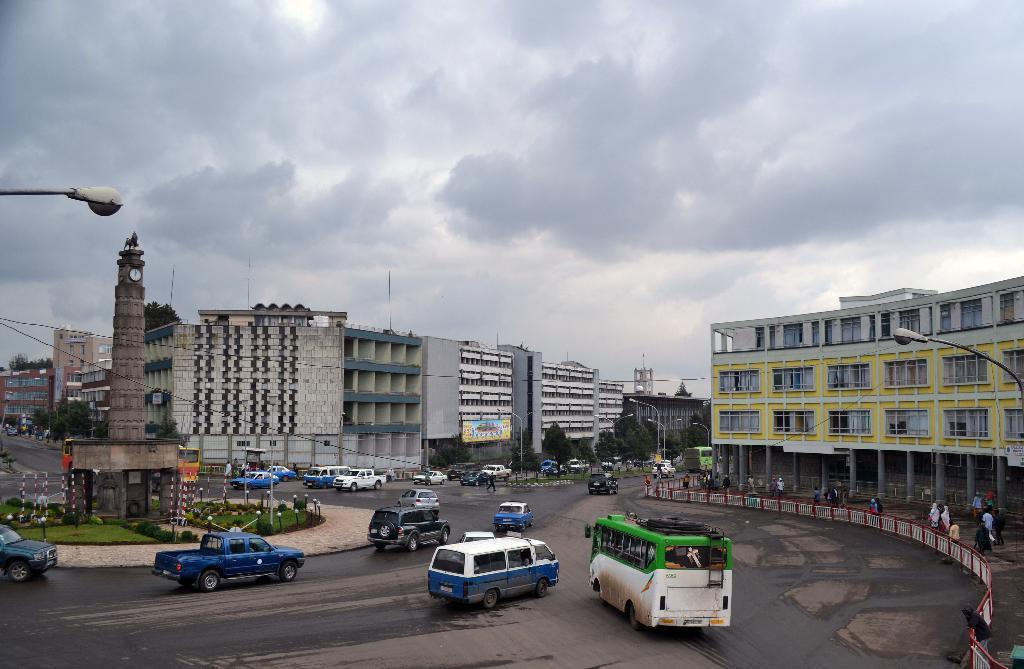What is happening at the bottom of the image? There are vehicles moving on the road at the bottom of the image. What type of structures can be seen in the image? There are big buildings in the image. What is visible at the top of the image? The sky is cloudy at the top of the image. Where is the playground located in the image? There is no playground present in the image. How many bikes can be seen in the image? There are no bikes visible in the image. 